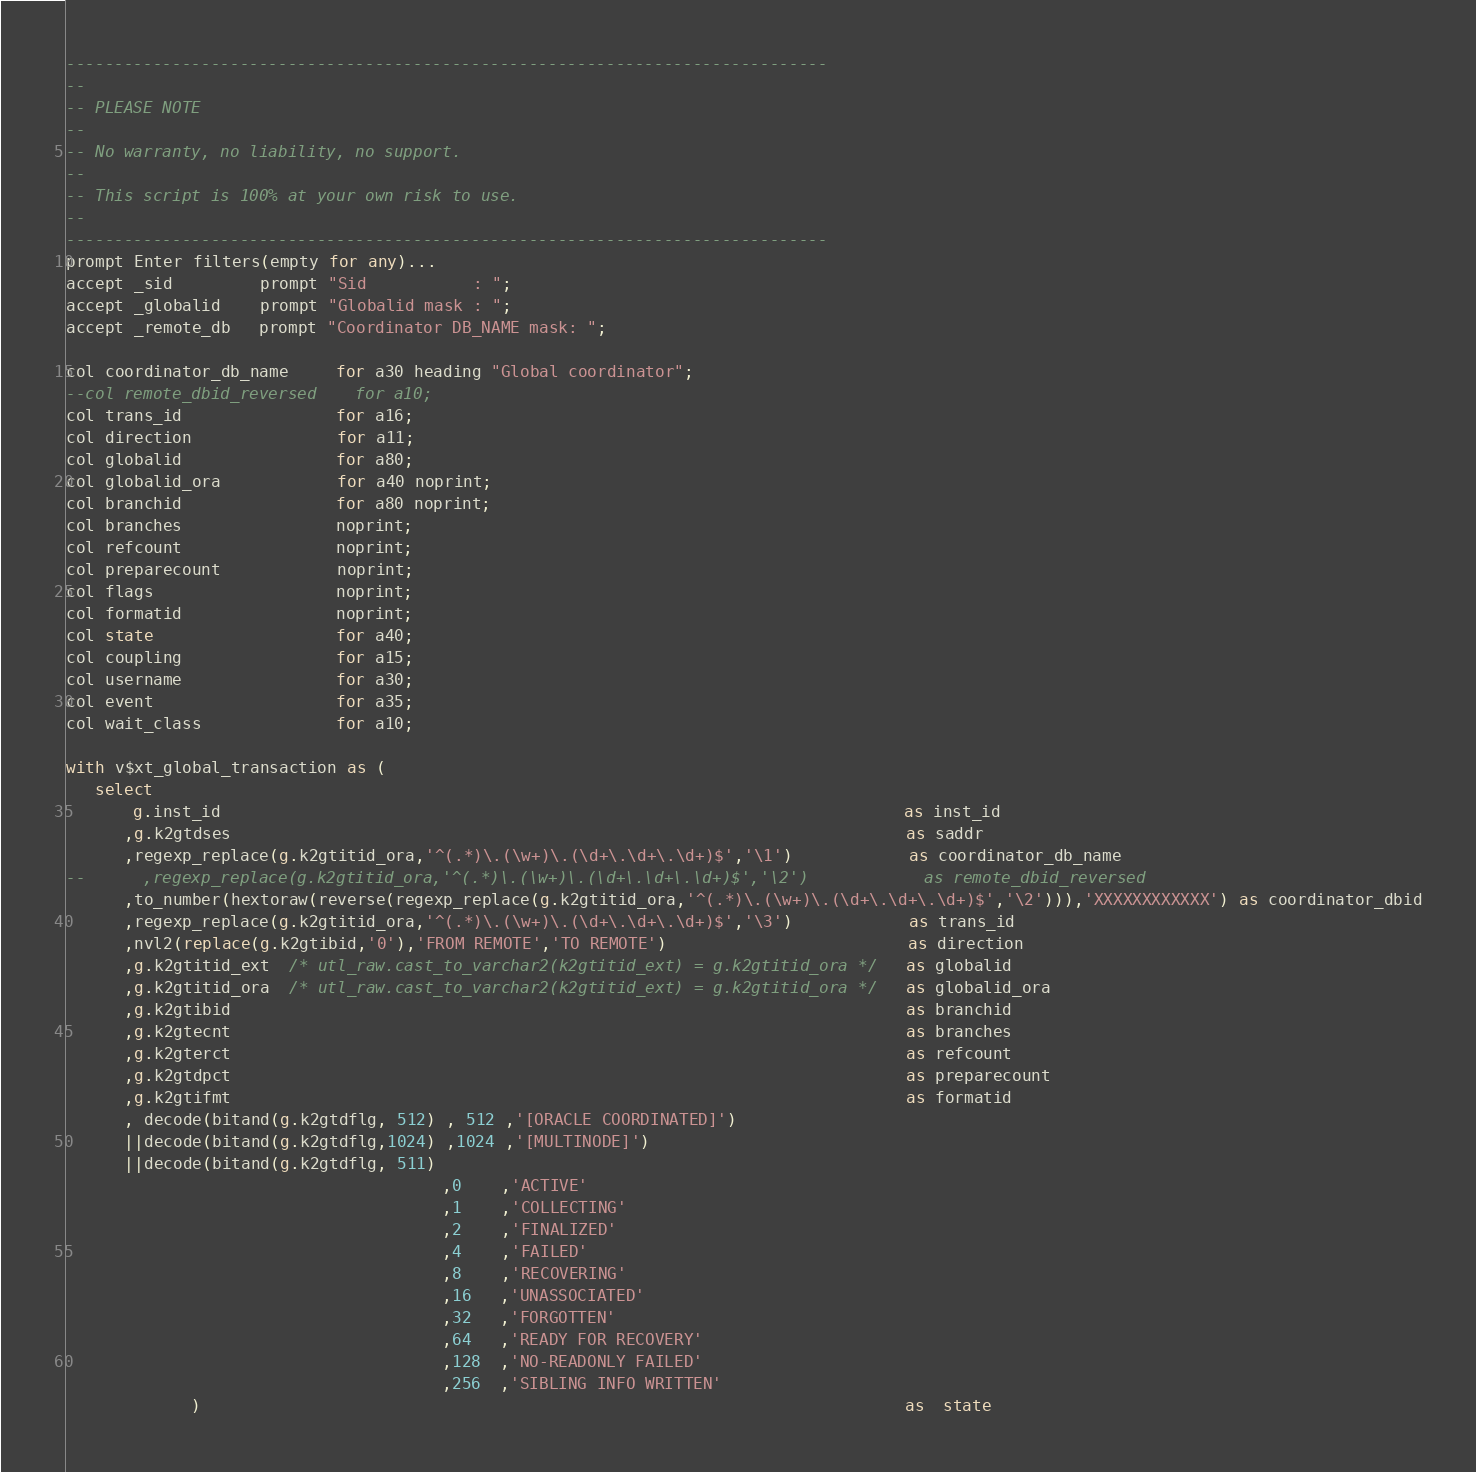Convert code to text. <code><loc_0><loc_0><loc_500><loc_500><_SQL_>-------------------------------------------------------------------------------
--
-- PLEASE NOTE
-- 
-- No warranty, no liability, no support.
--
-- This script is 100% at your own risk to use.
--
-------------------------------------------------------------------------------
prompt Enter filters(empty for any)...
accept _sid         prompt "Sid           : ";
accept _globalid    prompt "Globalid mask : ";
accept _remote_db   prompt "Coordinator DB_NAME mask: ";

col coordinator_db_name     for a30 heading "Global coordinator";
--col remote_dbid_reversed    for a10;
col trans_id                for a16;
col direction               for a11;
col globalid                for a80;
col globalid_ora            for a40 noprint;
col branchid                for a80 noprint;
col branches                noprint;
col refcount                noprint;
col preparecount            noprint;
col flags                   noprint;
col formatid                noprint;
col state                   for a40;
col coupling                for a15;
col username                for a30;
col event                   for a35;
col wait_class              for a10;

with v$xt_global_transaction as (
   select
       g.inst_id                                                                       as inst_id
      ,g.k2gtdses                                                                      as saddr
      ,regexp_replace(g.k2gtitid_ora,'^(.*)\.(\w+)\.(\d+\.\d+\.\d+)$','\1')            as coordinator_db_name
--      ,regexp_replace(g.k2gtitid_ora,'^(.*)\.(\w+)\.(\d+\.\d+\.\d+)$','\2')            as remote_dbid_reversed
      ,to_number(hextoraw(reverse(regexp_replace(g.k2gtitid_ora,'^(.*)\.(\w+)\.(\d+\.\d+\.\d+)$','\2'))),'XXXXXXXXXXXX') as coordinator_dbid
      ,regexp_replace(g.k2gtitid_ora,'^(.*)\.(\w+)\.(\d+\.\d+\.\d+)$','\3')            as trans_id
      ,nvl2(replace(g.k2gtibid,'0'),'FROM REMOTE','TO REMOTE')                         as direction
      ,g.k2gtitid_ext  /* utl_raw.cast_to_varchar2(k2gtitid_ext) = g.k2gtitid_ora */   as globalid    
      ,g.k2gtitid_ora  /* utl_raw.cast_to_varchar2(k2gtitid_ext) = g.k2gtitid_ora */   as globalid_ora
      ,g.k2gtibid                                                                      as branchid
      ,g.k2gtecnt                                                                      as branches
      ,g.k2gterct                                                                      as refcount
      ,g.k2gtdpct                                                                      as preparecount
      ,g.k2gtifmt                                                                      as formatid
      , decode(bitand(g.k2gtdflg, 512) , 512 ,'[ORACLE COORDINATED]')
      ||decode(bitand(g.k2gtdflg,1024) ,1024 ,'[MULTINODE]')
      ||decode(bitand(g.k2gtdflg, 511)
                                       ,0    ,'ACTIVE'
                                       ,1    ,'COLLECTING'
                                       ,2    ,'FINALIZED'
                                       ,4    ,'FAILED'
                                       ,8    ,'RECOVERING'
                                       ,16   ,'UNASSOCIATED'
                                       ,32   ,'FORGOTTEN'
                                       ,64   ,'READY FOR RECOVERY'
                                       ,128  ,'NO-READONLY FAILED'
                                       ,256  ,'SIBLING INFO WRITTEN'
             )                                                                         as  state</code> 